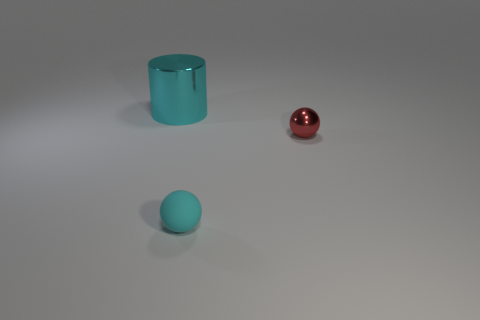Add 3 tiny yellow spheres. How many objects exist? 6 Add 2 balls. How many balls exist? 4 Subtract 0 blue cubes. How many objects are left? 3 Subtract all cylinders. How many objects are left? 2 Subtract 2 spheres. How many spheres are left? 0 Subtract all cyan balls. Subtract all brown cylinders. How many balls are left? 1 Subtract all green cubes. How many cyan balls are left? 1 Subtract all cyan metallic cubes. Subtract all rubber objects. How many objects are left? 2 Add 3 cyan objects. How many cyan objects are left? 5 